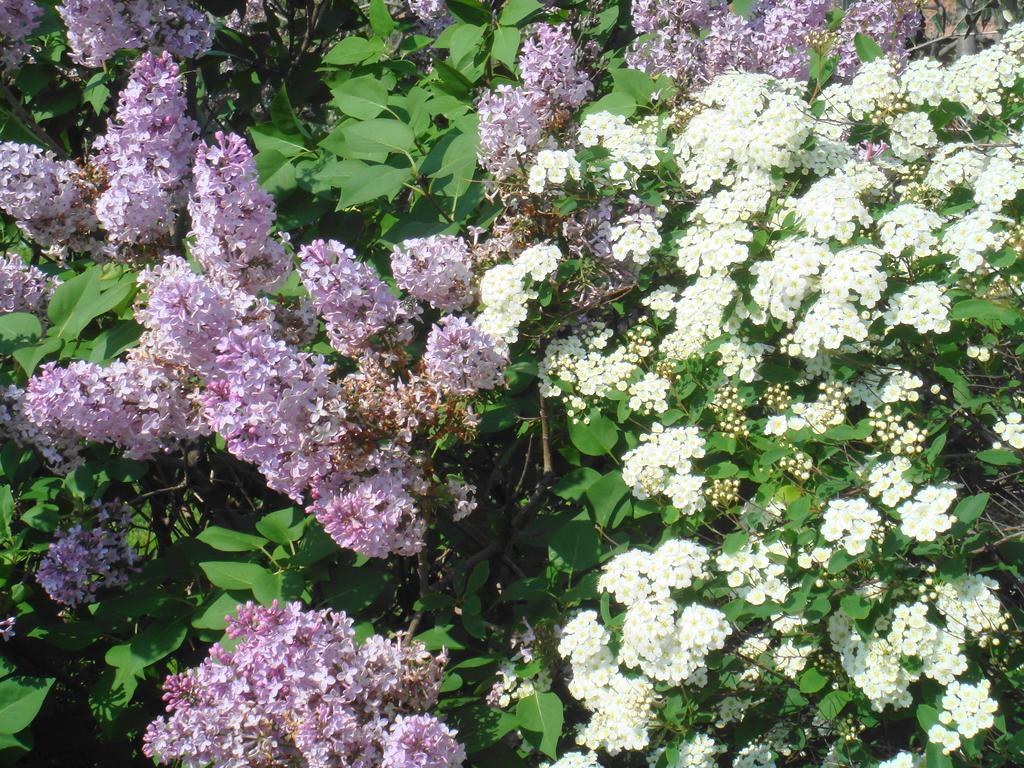Describe this image in one or two sentences. In this image, I can see the trees with the flowers, leaves and branches. These flowers are purple and white in color. 